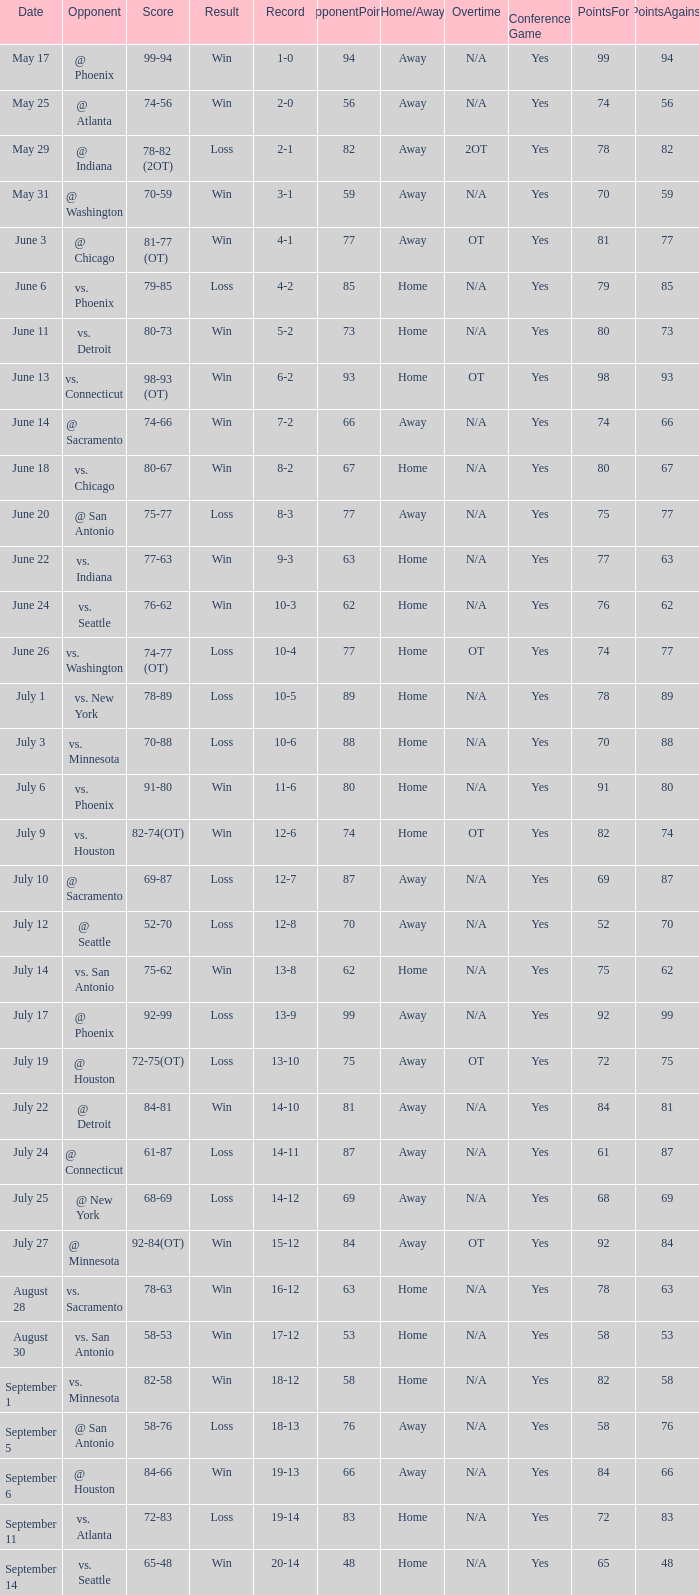Who is the adversary in the game with a score of 74-66? @ Sacramento. 